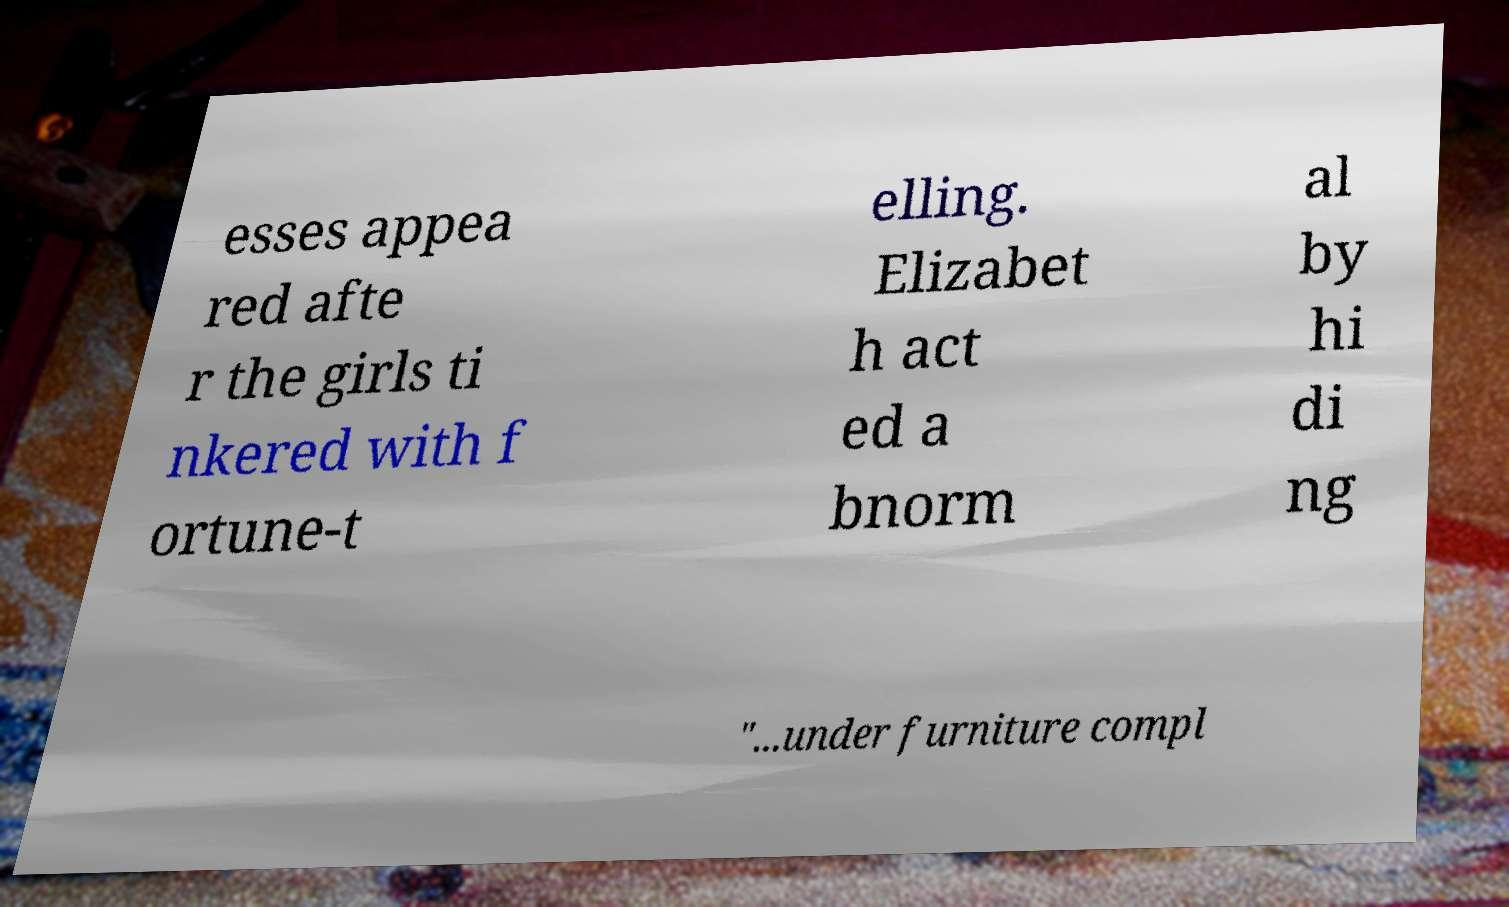Could you extract and type out the text from this image? esses appea red afte r the girls ti nkered with f ortune-t elling. Elizabet h act ed a bnorm al by hi di ng "...under furniture compl 